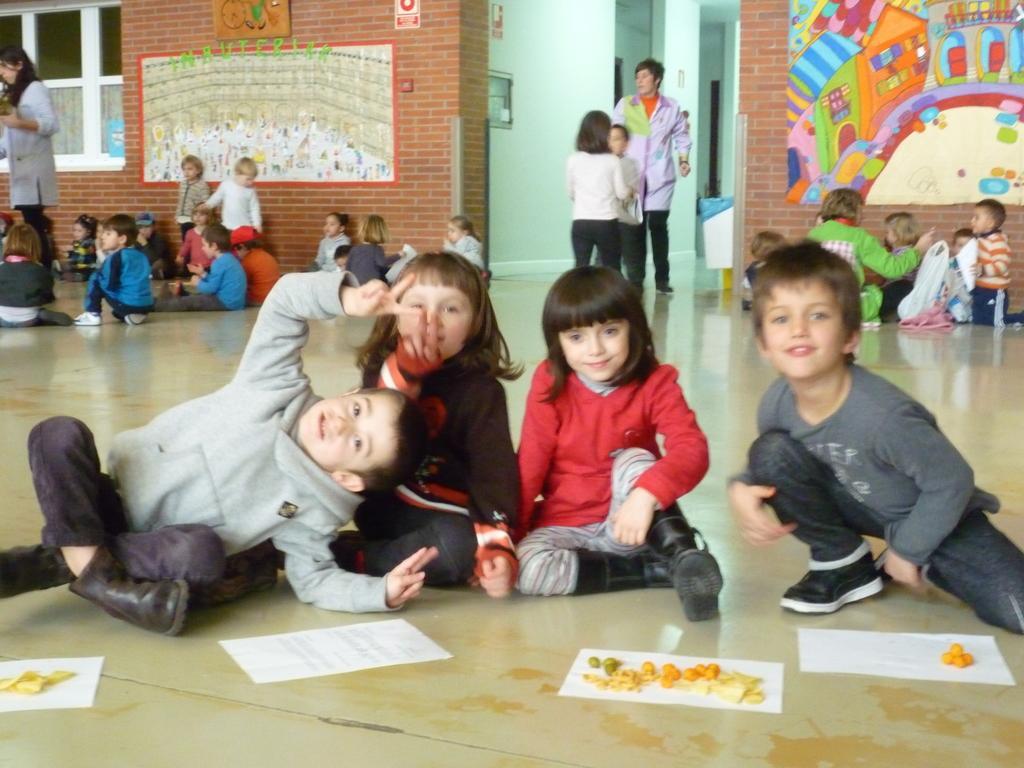Can you describe this image briefly? In this image I can see some kids on the floor. I can see something on the paper. In the background, I can see some painting on the wall. 